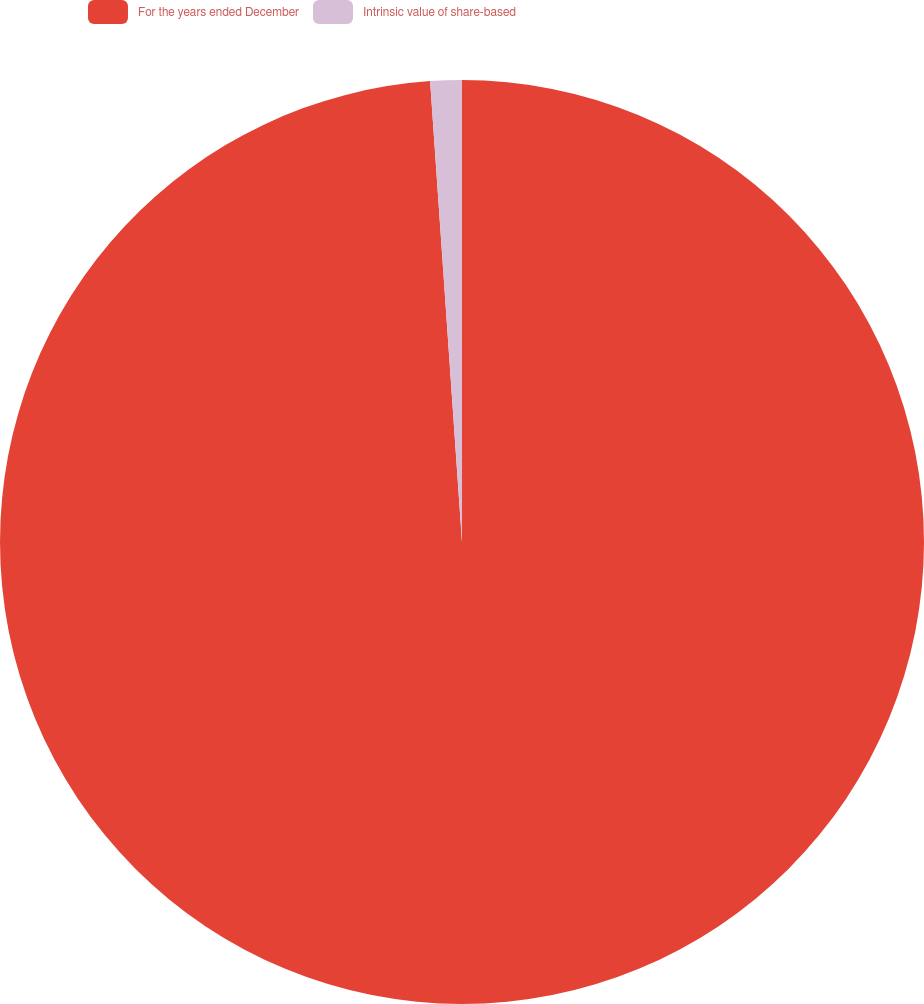Convert chart to OTSL. <chart><loc_0><loc_0><loc_500><loc_500><pie_chart><fcel>For the years ended December<fcel>Intrinsic value of share-based<nl><fcel>98.9%<fcel>1.1%<nl></chart> 